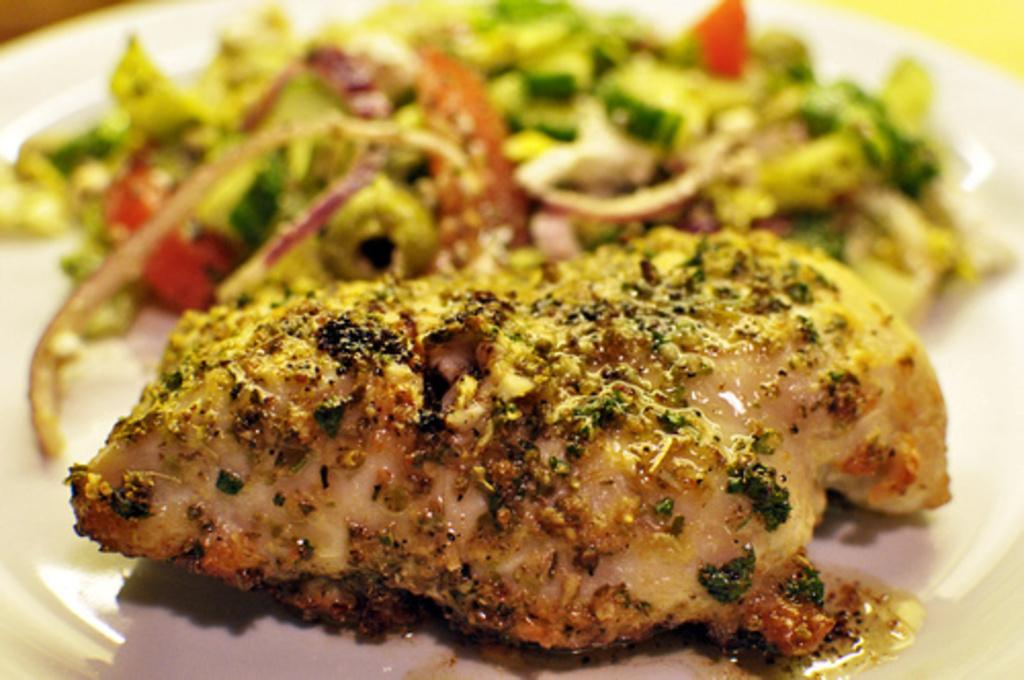What is present on the plate in the image? There is food on the plate, including onions, red bell pepper, zucchini, and meat. Can you describe the type of food on the plate? The food on the plate includes onions, red bell pepper, zucchini, and meat. Are there any other vegetables on the plate besides onions, red bell pepper, and zucchini? No, those are the only vegetables mentioned in the facts. How does the horse interact with the ticket in the image? There is no horse or ticket present in the image. What trick can be performed with the food on the plate in the image? The facts provided do not mention any tricks related to the food on the plate. 